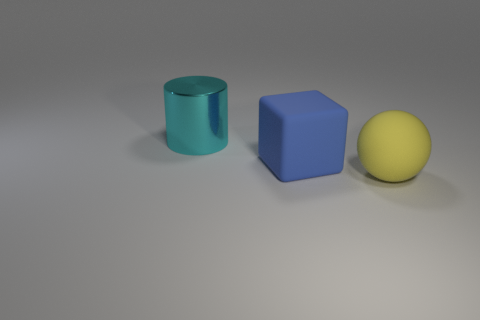There is a rubber object that is to the left of the thing right of the big blue matte block; what is its size?
Your answer should be compact. Large. How many other things are there of the same size as the blue object?
Your response must be concise. 2. How many cyan things are there?
Your answer should be compact. 1. How many other things are there of the same shape as the blue object?
Your answer should be very brief. 0. What material is the big object to the right of the big rubber thing that is to the left of the rubber ball made of?
Keep it short and to the point. Rubber. There is a blue matte block; are there any big spheres on the left side of it?
Offer a terse response. No. There is a block; is its size the same as the shiny cylinder that is to the left of the large blue matte block?
Your answer should be compact. Yes. Are there any other things that are the same material as the cylinder?
Offer a very short reply. No. How many large objects are yellow things or metal cylinders?
Offer a terse response. 2. How many large objects are behind the sphere and on the right side of the big cylinder?
Give a very brief answer. 1. 